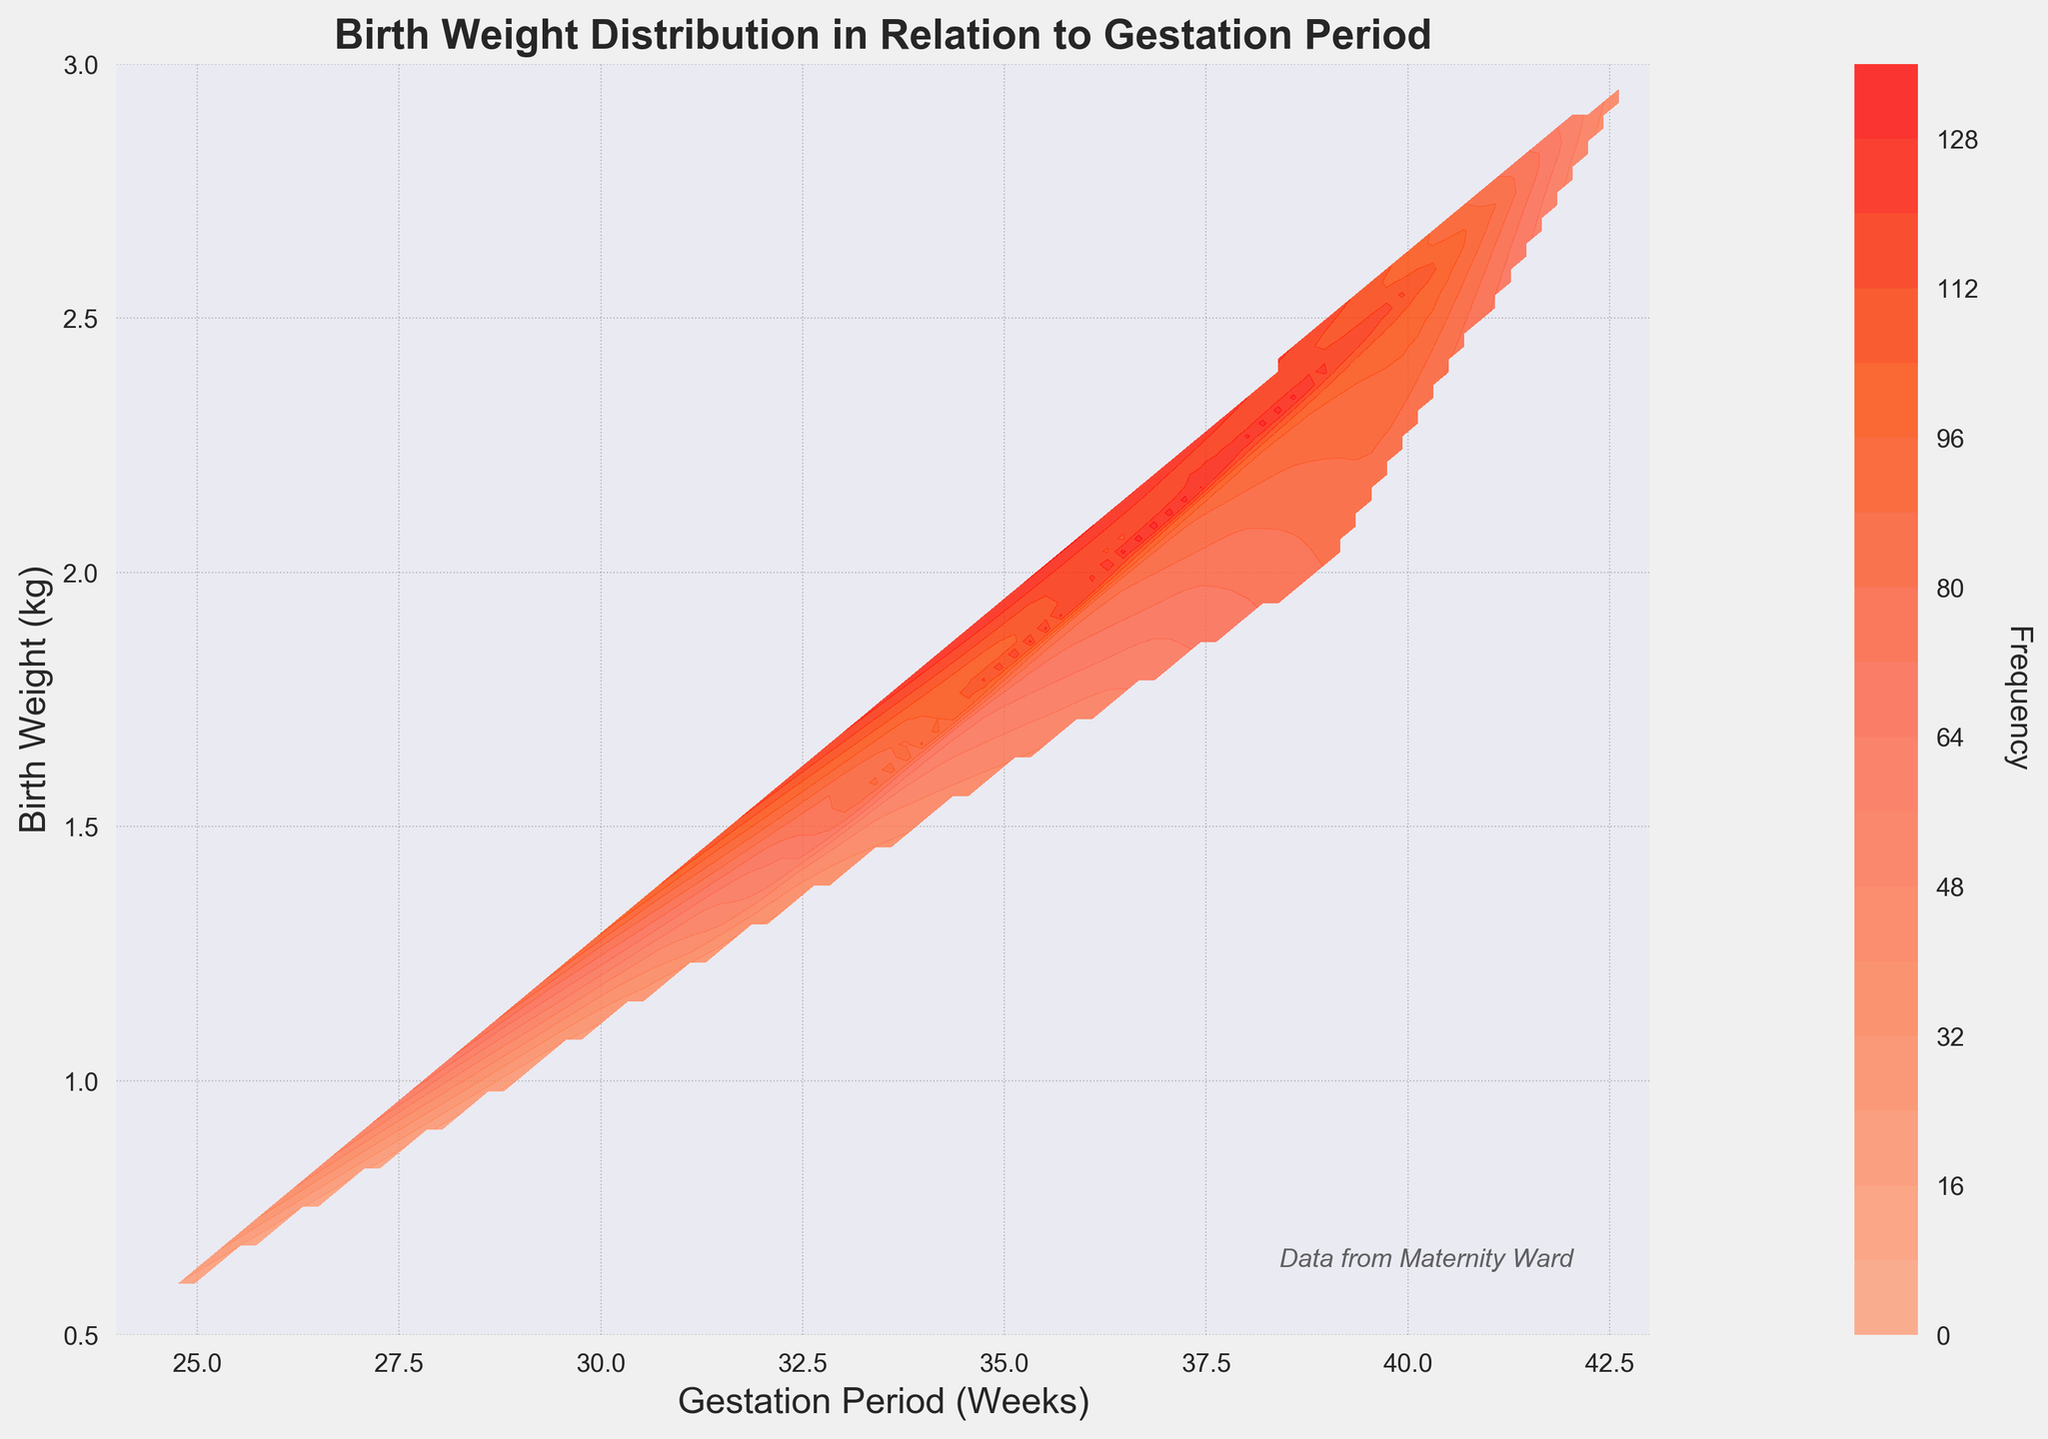What is the title of the figure? The title is found at the top of the plot. It is in bold and summarizes the content depicted in the plot.
Answer: Birth Weight Distribution in Relation to Gestation Period What are the units for the x-axis and y-axis? The units for the x-axis and y-axis are labeled respectively at the bottom and side of the graph.
Answer: Weeks for x-axis, kg for y-axis What is the general trend observed in the birth weight distribution as the gestation period increases? As you move from left to right along the x-axis, which represents an increasing gestation period, observe the contour lines showing higher birth weights and frequencies.
Answer: Birth weight generally increases Which gestation period has the highest birth weight frequency according to the plot? Look for the most densely colored contour area, indicating the highest frequency. Check the corresponding x-axis value.
Answer: 40 weeks How does the birth weight at 41 weeks compare to that at 39 weeks? Compare the color shading at 41 weeks and 39 weeks. Darker colors correspond to higher frequencies, and note any weight changes.
Answer: Higher frequency at 39 weeks What is the frequency of births at 38 weeks with a weight of 1.9 kg? Identify the contour line or shaded area representing 38 weeks on the x-axis and 1.9 kg on the y-axis. Check the corresponding contour level or color shade.
Answer: 70 At what gestation period do babies typically weigh around 2.5 kg? Find the y-axis value of 2.5 kg and see where it intersects most densely with the x-axis representing the gestation period.
Answer: 40 weeks Is there a higher frequency of births at 41 weeks and 2.7 kg than at 42 weeks and 2.9 kg? Compare the contour levels or color shades between these two points: 41 weeks and 2.7 kg versus 42 weeks and 2.9 kg.
Answer: Yes, higher at 41 weeks and 2.7 kg Between 37 weeks and 40 weeks, which gestation period shows a sharper increase in birth weight? Analyze the contour lines' slope between these weeks. Steeper slopes indicate sharper increases in birth weight.
Answer: 40 weeks What visual indications are used to represent frequency in the contour plot? The contour plot uses a gradient of colors where darker or more intense colors represent higher frequencies.
Answer: Color shading 